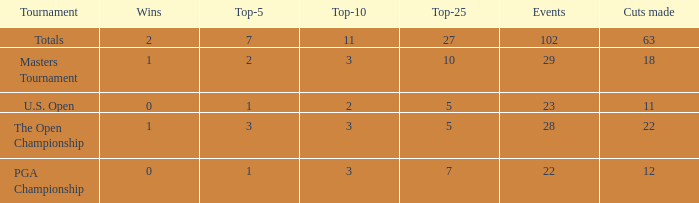How many top 10s associated with 3 top 5s and under 22 cuts made? None. 